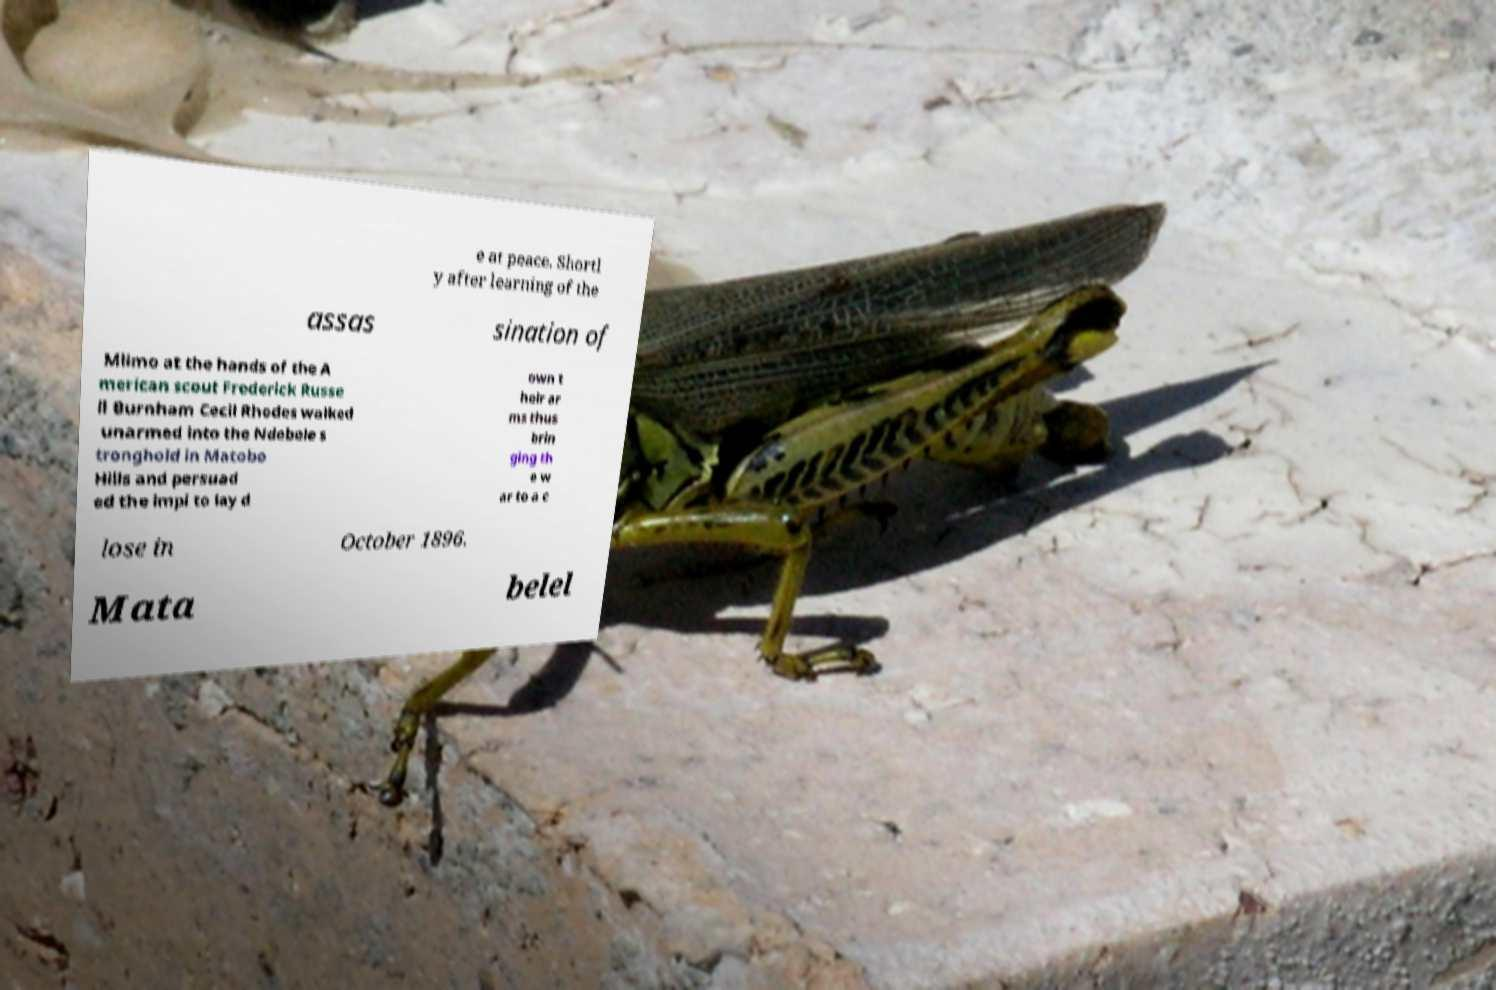For documentation purposes, I need the text within this image transcribed. Could you provide that? e at peace. Shortl y after learning of the assas sination of Mlimo at the hands of the A merican scout Frederick Russe ll Burnham Cecil Rhodes walked unarmed into the Ndebele s tronghold in Matobo Hills and persuad ed the impi to lay d own t heir ar ms thus brin ging th e w ar to a c lose in October 1896. Mata belel 